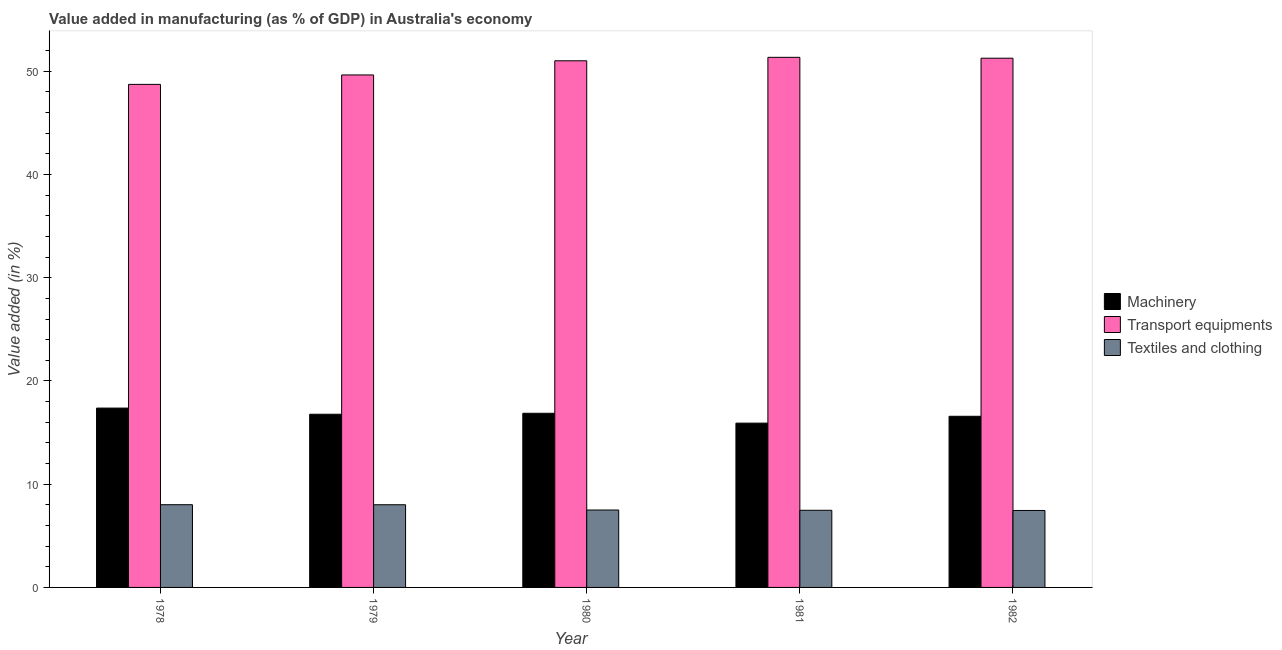How many different coloured bars are there?
Ensure brevity in your answer.  3. How many groups of bars are there?
Make the answer very short. 5. Are the number of bars on each tick of the X-axis equal?
Make the answer very short. Yes. What is the label of the 1st group of bars from the left?
Provide a succinct answer. 1978. In how many cases, is the number of bars for a given year not equal to the number of legend labels?
Offer a very short reply. 0. What is the value added in manufacturing textile and clothing in 1978?
Your answer should be compact. 8.01. Across all years, what is the maximum value added in manufacturing machinery?
Offer a terse response. 17.37. Across all years, what is the minimum value added in manufacturing transport equipments?
Give a very brief answer. 48.73. In which year was the value added in manufacturing textile and clothing maximum?
Ensure brevity in your answer.  1978. In which year was the value added in manufacturing textile and clothing minimum?
Keep it short and to the point. 1982. What is the total value added in manufacturing machinery in the graph?
Make the answer very short. 83.51. What is the difference between the value added in manufacturing textile and clothing in 1979 and that in 1980?
Offer a terse response. 0.51. What is the difference between the value added in manufacturing textile and clothing in 1982 and the value added in manufacturing machinery in 1980?
Your response must be concise. -0.05. What is the average value added in manufacturing transport equipments per year?
Keep it short and to the point. 50.4. In how many years, is the value added in manufacturing machinery greater than 46 %?
Your answer should be compact. 0. What is the ratio of the value added in manufacturing transport equipments in 1978 to that in 1982?
Your answer should be compact. 0.95. What is the difference between the highest and the second highest value added in manufacturing machinery?
Provide a succinct answer. 0.5. What is the difference between the highest and the lowest value added in manufacturing machinery?
Provide a succinct answer. 1.46. Is the sum of the value added in manufacturing transport equipments in 1980 and 1981 greater than the maximum value added in manufacturing machinery across all years?
Offer a terse response. Yes. What does the 3rd bar from the left in 1979 represents?
Offer a very short reply. Textiles and clothing. What does the 2nd bar from the right in 1982 represents?
Provide a succinct answer. Transport equipments. Is it the case that in every year, the sum of the value added in manufacturing machinery and value added in manufacturing transport equipments is greater than the value added in manufacturing textile and clothing?
Keep it short and to the point. Yes. How many bars are there?
Give a very brief answer. 15. How many years are there in the graph?
Your answer should be very brief. 5. What is the difference between two consecutive major ticks on the Y-axis?
Your response must be concise. 10. Are the values on the major ticks of Y-axis written in scientific E-notation?
Make the answer very short. No. Does the graph contain grids?
Provide a short and direct response. No. Where does the legend appear in the graph?
Your answer should be very brief. Center right. How many legend labels are there?
Offer a terse response. 3. What is the title of the graph?
Offer a terse response. Value added in manufacturing (as % of GDP) in Australia's economy. Does "Neonatal" appear as one of the legend labels in the graph?
Give a very brief answer. No. What is the label or title of the Y-axis?
Provide a succinct answer. Value added (in %). What is the Value added (in %) in Machinery in 1978?
Offer a very short reply. 17.37. What is the Value added (in %) of Transport equipments in 1978?
Offer a terse response. 48.73. What is the Value added (in %) in Textiles and clothing in 1978?
Provide a succinct answer. 8.01. What is the Value added (in %) of Machinery in 1979?
Keep it short and to the point. 16.78. What is the Value added (in %) of Transport equipments in 1979?
Keep it short and to the point. 49.64. What is the Value added (in %) of Textiles and clothing in 1979?
Offer a terse response. 8.01. What is the Value added (in %) of Machinery in 1980?
Provide a short and direct response. 16.87. What is the Value added (in %) in Transport equipments in 1980?
Give a very brief answer. 51.02. What is the Value added (in %) of Textiles and clothing in 1980?
Offer a very short reply. 7.5. What is the Value added (in %) of Machinery in 1981?
Make the answer very short. 15.92. What is the Value added (in %) in Transport equipments in 1981?
Offer a terse response. 51.35. What is the Value added (in %) of Textiles and clothing in 1981?
Keep it short and to the point. 7.47. What is the Value added (in %) of Machinery in 1982?
Your response must be concise. 16.58. What is the Value added (in %) of Transport equipments in 1982?
Your answer should be compact. 51.27. What is the Value added (in %) of Textiles and clothing in 1982?
Your answer should be very brief. 7.45. Across all years, what is the maximum Value added (in %) of Machinery?
Give a very brief answer. 17.37. Across all years, what is the maximum Value added (in %) of Transport equipments?
Offer a very short reply. 51.35. Across all years, what is the maximum Value added (in %) in Textiles and clothing?
Your answer should be very brief. 8.01. Across all years, what is the minimum Value added (in %) of Machinery?
Give a very brief answer. 15.92. Across all years, what is the minimum Value added (in %) in Transport equipments?
Make the answer very short. 48.73. Across all years, what is the minimum Value added (in %) in Textiles and clothing?
Keep it short and to the point. 7.45. What is the total Value added (in %) in Machinery in the graph?
Provide a short and direct response. 83.51. What is the total Value added (in %) in Transport equipments in the graph?
Offer a very short reply. 252.01. What is the total Value added (in %) of Textiles and clothing in the graph?
Ensure brevity in your answer.  38.45. What is the difference between the Value added (in %) in Machinery in 1978 and that in 1979?
Your response must be concise. 0.6. What is the difference between the Value added (in %) of Transport equipments in 1978 and that in 1979?
Offer a terse response. -0.91. What is the difference between the Value added (in %) in Textiles and clothing in 1978 and that in 1979?
Ensure brevity in your answer.  0. What is the difference between the Value added (in %) of Machinery in 1978 and that in 1980?
Keep it short and to the point. 0.5. What is the difference between the Value added (in %) in Transport equipments in 1978 and that in 1980?
Your answer should be compact. -2.28. What is the difference between the Value added (in %) of Textiles and clothing in 1978 and that in 1980?
Ensure brevity in your answer.  0.51. What is the difference between the Value added (in %) of Machinery in 1978 and that in 1981?
Your response must be concise. 1.46. What is the difference between the Value added (in %) of Transport equipments in 1978 and that in 1981?
Your answer should be compact. -2.62. What is the difference between the Value added (in %) in Textiles and clothing in 1978 and that in 1981?
Provide a short and direct response. 0.54. What is the difference between the Value added (in %) in Machinery in 1978 and that in 1982?
Provide a short and direct response. 0.79. What is the difference between the Value added (in %) in Transport equipments in 1978 and that in 1982?
Your response must be concise. -2.54. What is the difference between the Value added (in %) of Textiles and clothing in 1978 and that in 1982?
Keep it short and to the point. 0.56. What is the difference between the Value added (in %) of Machinery in 1979 and that in 1980?
Your answer should be compact. -0.09. What is the difference between the Value added (in %) in Transport equipments in 1979 and that in 1980?
Offer a terse response. -1.37. What is the difference between the Value added (in %) in Textiles and clothing in 1979 and that in 1980?
Make the answer very short. 0.51. What is the difference between the Value added (in %) of Machinery in 1979 and that in 1981?
Provide a succinct answer. 0.86. What is the difference between the Value added (in %) of Transport equipments in 1979 and that in 1981?
Offer a terse response. -1.71. What is the difference between the Value added (in %) in Textiles and clothing in 1979 and that in 1981?
Offer a terse response. 0.54. What is the difference between the Value added (in %) of Machinery in 1979 and that in 1982?
Provide a short and direct response. 0.2. What is the difference between the Value added (in %) in Transport equipments in 1979 and that in 1982?
Your response must be concise. -1.62. What is the difference between the Value added (in %) of Textiles and clothing in 1979 and that in 1982?
Provide a short and direct response. 0.56. What is the difference between the Value added (in %) in Machinery in 1980 and that in 1981?
Your response must be concise. 0.95. What is the difference between the Value added (in %) in Transport equipments in 1980 and that in 1981?
Offer a very short reply. -0.34. What is the difference between the Value added (in %) in Textiles and clothing in 1980 and that in 1981?
Offer a terse response. 0.03. What is the difference between the Value added (in %) in Machinery in 1980 and that in 1982?
Offer a very short reply. 0.29. What is the difference between the Value added (in %) in Transport equipments in 1980 and that in 1982?
Offer a very short reply. -0.25. What is the difference between the Value added (in %) in Textiles and clothing in 1980 and that in 1982?
Provide a succinct answer. 0.05. What is the difference between the Value added (in %) in Machinery in 1981 and that in 1982?
Make the answer very short. -0.66. What is the difference between the Value added (in %) in Transport equipments in 1981 and that in 1982?
Your answer should be very brief. 0.08. What is the difference between the Value added (in %) in Textiles and clothing in 1981 and that in 1982?
Offer a terse response. 0.02. What is the difference between the Value added (in %) of Machinery in 1978 and the Value added (in %) of Transport equipments in 1979?
Your answer should be compact. -32.27. What is the difference between the Value added (in %) of Machinery in 1978 and the Value added (in %) of Textiles and clothing in 1979?
Ensure brevity in your answer.  9.36. What is the difference between the Value added (in %) of Transport equipments in 1978 and the Value added (in %) of Textiles and clothing in 1979?
Offer a very short reply. 40.72. What is the difference between the Value added (in %) of Machinery in 1978 and the Value added (in %) of Transport equipments in 1980?
Offer a terse response. -33.64. What is the difference between the Value added (in %) of Machinery in 1978 and the Value added (in %) of Textiles and clothing in 1980?
Give a very brief answer. 9.87. What is the difference between the Value added (in %) in Transport equipments in 1978 and the Value added (in %) in Textiles and clothing in 1980?
Make the answer very short. 41.23. What is the difference between the Value added (in %) in Machinery in 1978 and the Value added (in %) in Transport equipments in 1981?
Offer a terse response. -33.98. What is the difference between the Value added (in %) of Machinery in 1978 and the Value added (in %) of Textiles and clothing in 1981?
Your answer should be very brief. 9.9. What is the difference between the Value added (in %) in Transport equipments in 1978 and the Value added (in %) in Textiles and clothing in 1981?
Make the answer very short. 41.26. What is the difference between the Value added (in %) of Machinery in 1978 and the Value added (in %) of Transport equipments in 1982?
Ensure brevity in your answer.  -33.89. What is the difference between the Value added (in %) of Machinery in 1978 and the Value added (in %) of Textiles and clothing in 1982?
Provide a short and direct response. 9.92. What is the difference between the Value added (in %) in Transport equipments in 1978 and the Value added (in %) in Textiles and clothing in 1982?
Provide a succinct answer. 41.28. What is the difference between the Value added (in %) of Machinery in 1979 and the Value added (in %) of Transport equipments in 1980?
Your response must be concise. -34.24. What is the difference between the Value added (in %) of Machinery in 1979 and the Value added (in %) of Textiles and clothing in 1980?
Make the answer very short. 9.28. What is the difference between the Value added (in %) in Transport equipments in 1979 and the Value added (in %) in Textiles and clothing in 1980?
Offer a very short reply. 42.14. What is the difference between the Value added (in %) in Machinery in 1979 and the Value added (in %) in Transport equipments in 1981?
Provide a succinct answer. -34.57. What is the difference between the Value added (in %) of Machinery in 1979 and the Value added (in %) of Textiles and clothing in 1981?
Provide a short and direct response. 9.3. What is the difference between the Value added (in %) of Transport equipments in 1979 and the Value added (in %) of Textiles and clothing in 1981?
Provide a short and direct response. 42.17. What is the difference between the Value added (in %) of Machinery in 1979 and the Value added (in %) of Transport equipments in 1982?
Your answer should be compact. -34.49. What is the difference between the Value added (in %) of Machinery in 1979 and the Value added (in %) of Textiles and clothing in 1982?
Your answer should be compact. 9.32. What is the difference between the Value added (in %) of Transport equipments in 1979 and the Value added (in %) of Textiles and clothing in 1982?
Offer a very short reply. 42.19. What is the difference between the Value added (in %) in Machinery in 1980 and the Value added (in %) in Transport equipments in 1981?
Ensure brevity in your answer.  -34.48. What is the difference between the Value added (in %) in Machinery in 1980 and the Value added (in %) in Textiles and clothing in 1981?
Offer a very short reply. 9.4. What is the difference between the Value added (in %) of Transport equipments in 1980 and the Value added (in %) of Textiles and clothing in 1981?
Your answer should be compact. 43.54. What is the difference between the Value added (in %) in Machinery in 1980 and the Value added (in %) in Transport equipments in 1982?
Provide a short and direct response. -34.4. What is the difference between the Value added (in %) in Machinery in 1980 and the Value added (in %) in Textiles and clothing in 1982?
Ensure brevity in your answer.  9.42. What is the difference between the Value added (in %) in Transport equipments in 1980 and the Value added (in %) in Textiles and clothing in 1982?
Ensure brevity in your answer.  43.56. What is the difference between the Value added (in %) in Machinery in 1981 and the Value added (in %) in Transport equipments in 1982?
Give a very brief answer. -35.35. What is the difference between the Value added (in %) in Machinery in 1981 and the Value added (in %) in Textiles and clothing in 1982?
Offer a very short reply. 8.46. What is the difference between the Value added (in %) of Transport equipments in 1981 and the Value added (in %) of Textiles and clothing in 1982?
Provide a short and direct response. 43.9. What is the average Value added (in %) in Machinery per year?
Give a very brief answer. 16.7. What is the average Value added (in %) in Transport equipments per year?
Ensure brevity in your answer.  50.4. What is the average Value added (in %) in Textiles and clothing per year?
Provide a short and direct response. 7.69. In the year 1978, what is the difference between the Value added (in %) of Machinery and Value added (in %) of Transport equipments?
Offer a terse response. -31.36. In the year 1978, what is the difference between the Value added (in %) of Machinery and Value added (in %) of Textiles and clothing?
Offer a terse response. 9.36. In the year 1978, what is the difference between the Value added (in %) in Transport equipments and Value added (in %) in Textiles and clothing?
Provide a succinct answer. 40.72. In the year 1979, what is the difference between the Value added (in %) of Machinery and Value added (in %) of Transport equipments?
Your response must be concise. -32.87. In the year 1979, what is the difference between the Value added (in %) of Machinery and Value added (in %) of Textiles and clothing?
Keep it short and to the point. 8.77. In the year 1979, what is the difference between the Value added (in %) of Transport equipments and Value added (in %) of Textiles and clothing?
Provide a short and direct response. 41.63. In the year 1980, what is the difference between the Value added (in %) of Machinery and Value added (in %) of Transport equipments?
Give a very brief answer. -34.15. In the year 1980, what is the difference between the Value added (in %) in Machinery and Value added (in %) in Textiles and clothing?
Your answer should be compact. 9.37. In the year 1980, what is the difference between the Value added (in %) of Transport equipments and Value added (in %) of Textiles and clothing?
Offer a very short reply. 43.52. In the year 1981, what is the difference between the Value added (in %) in Machinery and Value added (in %) in Transport equipments?
Your answer should be very brief. -35.44. In the year 1981, what is the difference between the Value added (in %) of Machinery and Value added (in %) of Textiles and clothing?
Keep it short and to the point. 8.44. In the year 1981, what is the difference between the Value added (in %) of Transport equipments and Value added (in %) of Textiles and clothing?
Make the answer very short. 43.88. In the year 1982, what is the difference between the Value added (in %) of Machinery and Value added (in %) of Transport equipments?
Ensure brevity in your answer.  -34.69. In the year 1982, what is the difference between the Value added (in %) of Machinery and Value added (in %) of Textiles and clothing?
Your response must be concise. 9.12. In the year 1982, what is the difference between the Value added (in %) in Transport equipments and Value added (in %) in Textiles and clothing?
Offer a terse response. 43.81. What is the ratio of the Value added (in %) of Machinery in 1978 to that in 1979?
Your answer should be compact. 1.04. What is the ratio of the Value added (in %) of Transport equipments in 1978 to that in 1979?
Make the answer very short. 0.98. What is the ratio of the Value added (in %) of Machinery in 1978 to that in 1980?
Offer a very short reply. 1.03. What is the ratio of the Value added (in %) of Transport equipments in 1978 to that in 1980?
Make the answer very short. 0.96. What is the ratio of the Value added (in %) of Textiles and clothing in 1978 to that in 1980?
Your answer should be compact. 1.07. What is the ratio of the Value added (in %) of Machinery in 1978 to that in 1981?
Provide a succinct answer. 1.09. What is the ratio of the Value added (in %) of Transport equipments in 1978 to that in 1981?
Your answer should be compact. 0.95. What is the ratio of the Value added (in %) of Textiles and clothing in 1978 to that in 1981?
Your answer should be very brief. 1.07. What is the ratio of the Value added (in %) in Machinery in 1978 to that in 1982?
Your answer should be very brief. 1.05. What is the ratio of the Value added (in %) in Transport equipments in 1978 to that in 1982?
Ensure brevity in your answer.  0.95. What is the ratio of the Value added (in %) of Textiles and clothing in 1978 to that in 1982?
Keep it short and to the point. 1.07. What is the ratio of the Value added (in %) of Transport equipments in 1979 to that in 1980?
Give a very brief answer. 0.97. What is the ratio of the Value added (in %) of Textiles and clothing in 1979 to that in 1980?
Keep it short and to the point. 1.07. What is the ratio of the Value added (in %) in Machinery in 1979 to that in 1981?
Your response must be concise. 1.05. What is the ratio of the Value added (in %) of Transport equipments in 1979 to that in 1981?
Provide a succinct answer. 0.97. What is the ratio of the Value added (in %) in Textiles and clothing in 1979 to that in 1981?
Offer a very short reply. 1.07. What is the ratio of the Value added (in %) in Machinery in 1979 to that in 1982?
Give a very brief answer. 1.01. What is the ratio of the Value added (in %) in Transport equipments in 1979 to that in 1982?
Keep it short and to the point. 0.97. What is the ratio of the Value added (in %) in Textiles and clothing in 1979 to that in 1982?
Ensure brevity in your answer.  1.07. What is the ratio of the Value added (in %) of Machinery in 1980 to that in 1981?
Make the answer very short. 1.06. What is the ratio of the Value added (in %) of Textiles and clothing in 1980 to that in 1981?
Your answer should be very brief. 1. What is the ratio of the Value added (in %) in Machinery in 1980 to that in 1982?
Offer a terse response. 1.02. What is the ratio of the Value added (in %) in Machinery in 1981 to that in 1982?
Your answer should be compact. 0.96. What is the ratio of the Value added (in %) of Transport equipments in 1981 to that in 1982?
Your response must be concise. 1. What is the ratio of the Value added (in %) of Textiles and clothing in 1981 to that in 1982?
Ensure brevity in your answer.  1. What is the difference between the highest and the second highest Value added (in %) of Machinery?
Keep it short and to the point. 0.5. What is the difference between the highest and the second highest Value added (in %) of Transport equipments?
Offer a terse response. 0.08. What is the difference between the highest and the second highest Value added (in %) in Textiles and clothing?
Your answer should be compact. 0. What is the difference between the highest and the lowest Value added (in %) in Machinery?
Provide a succinct answer. 1.46. What is the difference between the highest and the lowest Value added (in %) of Transport equipments?
Keep it short and to the point. 2.62. What is the difference between the highest and the lowest Value added (in %) in Textiles and clothing?
Your answer should be compact. 0.56. 